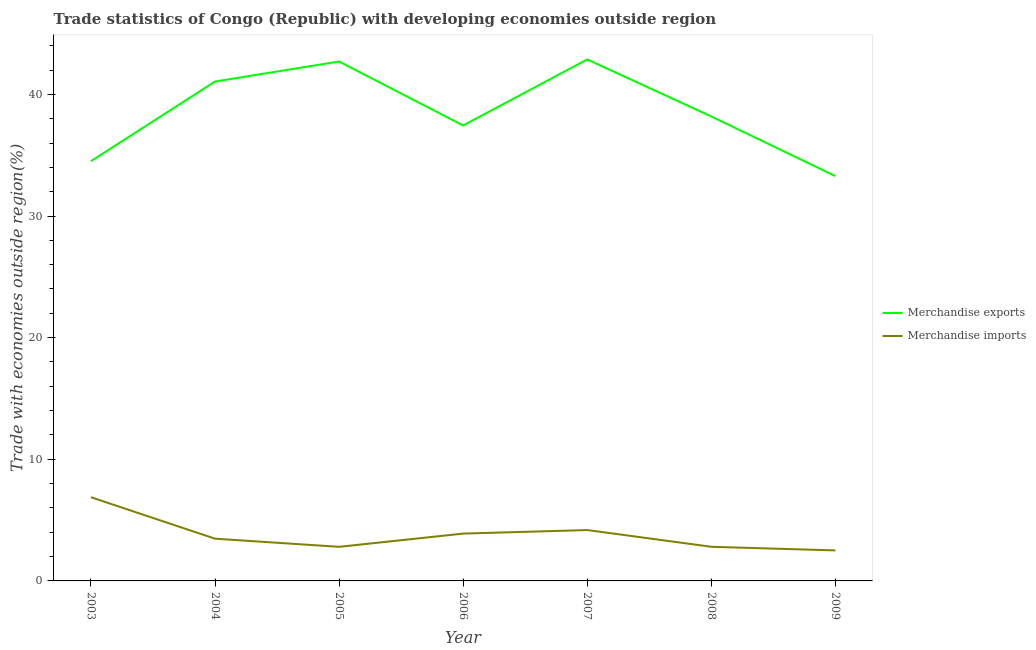How many different coloured lines are there?
Provide a succinct answer. 2. Is the number of lines equal to the number of legend labels?
Provide a succinct answer. Yes. What is the merchandise imports in 2008?
Give a very brief answer. 2.81. Across all years, what is the maximum merchandise imports?
Give a very brief answer. 6.88. Across all years, what is the minimum merchandise exports?
Provide a succinct answer. 33.28. What is the total merchandise exports in the graph?
Provide a short and direct response. 270.05. What is the difference between the merchandise imports in 2003 and that in 2007?
Offer a terse response. 2.7. What is the difference between the merchandise exports in 2006 and the merchandise imports in 2005?
Your response must be concise. 34.64. What is the average merchandise exports per year?
Your answer should be very brief. 38.58. In the year 2003, what is the difference between the merchandise imports and merchandise exports?
Offer a very short reply. -27.63. What is the ratio of the merchandise exports in 2006 to that in 2009?
Ensure brevity in your answer.  1.13. Is the difference between the merchandise exports in 2003 and 2007 greater than the difference between the merchandise imports in 2003 and 2007?
Your answer should be very brief. No. What is the difference between the highest and the second highest merchandise imports?
Provide a short and direct response. 2.7. What is the difference between the highest and the lowest merchandise exports?
Your answer should be very brief. 9.59. In how many years, is the merchandise exports greater than the average merchandise exports taken over all years?
Give a very brief answer. 3. Is the sum of the merchandise exports in 2007 and 2009 greater than the maximum merchandise imports across all years?
Your answer should be very brief. Yes. Is the merchandise exports strictly greater than the merchandise imports over the years?
Offer a very short reply. Yes. How many years are there in the graph?
Offer a very short reply. 7. Are the values on the major ticks of Y-axis written in scientific E-notation?
Keep it short and to the point. No. What is the title of the graph?
Offer a very short reply. Trade statistics of Congo (Republic) with developing economies outside region. What is the label or title of the X-axis?
Your response must be concise. Year. What is the label or title of the Y-axis?
Provide a succinct answer. Trade with economies outside region(%). What is the Trade with economies outside region(%) of Merchandise exports in 2003?
Provide a short and direct response. 34.51. What is the Trade with economies outside region(%) in Merchandise imports in 2003?
Your answer should be compact. 6.88. What is the Trade with economies outside region(%) in Merchandise exports in 2004?
Provide a succinct answer. 41.05. What is the Trade with economies outside region(%) of Merchandise imports in 2004?
Ensure brevity in your answer.  3.47. What is the Trade with economies outside region(%) in Merchandise exports in 2005?
Make the answer very short. 42.7. What is the Trade with economies outside region(%) in Merchandise imports in 2005?
Give a very brief answer. 2.8. What is the Trade with economies outside region(%) of Merchandise exports in 2006?
Provide a succinct answer. 37.44. What is the Trade with economies outside region(%) in Merchandise imports in 2006?
Your answer should be very brief. 3.89. What is the Trade with economies outside region(%) in Merchandise exports in 2007?
Your response must be concise. 42.87. What is the Trade with economies outside region(%) in Merchandise imports in 2007?
Give a very brief answer. 4.18. What is the Trade with economies outside region(%) of Merchandise exports in 2008?
Your response must be concise. 38.19. What is the Trade with economies outside region(%) of Merchandise imports in 2008?
Provide a succinct answer. 2.81. What is the Trade with economies outside region(%) of Merchandise exports in 2009?
Provide a succinct answer. 33.28. What is the Trade with economies outside region(%) in Merchandise imports in 2009?
Your answer should be very brief. 2.51. Across all years, what is the maximum Trade with economies outside region(%) in Merchandise exports?
Your response must be concise. 42.87. Across all years, what is the maximum Trade with economies outside region(%) in Merchandise imports?
Provide a short and direct response. 6.88. Across all years, what is the minimum Trade with economies outside region(%) of Merchandise exports?
Keep it short and to the point. 33.28. Across all years, what is the minimum Trade with economies outside region(%) in Merchandise imports?
Make the answer very short. 2.51. What is the total Trade with economies outside region(%) in Merchandise exports in the graph?
Provide a succinct answer. 270.05. What is the total Trade with economies outside region(%) in Merchandise imports in the graph?
Provide a succinct answer. 26.54. What is the difference between the Trade with economies outside region(%) of Merchandise exports in 2003 and that in 2004?
Keep it short and to the point. -6.55. What is the difference between the Trade with economies outside region(%) of Merchandise imports in 2003 and that in 2004?
Make the answer very short. 3.41. What is the difference between the Trade with economies outside region(%) of Merchandise exports in 2003 and that in 2005?
Your answer should be compact. -8.19. What is the difference between the Trade with economies outside region(%) in Merchandise imports in 2003 and that in 2005?
Offer a terse response. 4.08. What is the difference between the Trade with economies outside region(%) in Merchandise exports in 2003 and that in 2006?
Offer a terse response. -2.94. What is the difference between the Trade with economies outside region(%) of Merchandise imports in 2003 and that in 2006?
Give a very brief answer. 2.99. What is the difference between the Trade with economies outside region(%) in Merchandise exports in 2003 and that in 2007?
Your answer should be compact. -8.36. What is the difference between the Trade with economies outside region(%) of Merchandise imports in 2003 and that in 2007?
Offer a very short reply. 2.7. What is the difference between the Trade with economies outside region(%) of Merchandise exports in 2003 and that in 2008?
Your response must be concise. -3.68. What is the difference between the Trade with economies outside region(%) of Merchandise imports in 2003 and that in 2008?
Your response must be concise. 4.07. What is the difference between the Trade with economies outside region(%) in Merchandise exports in 2003 and that in 2009?
Give a very brief answer. 1.23. What is the difference between the Trade with economies outside region(%) of Merchandise imports in 2003 and that in 2009?
Offer a terse response. 4.37. What is the difference between the Trade with economies outside region(%) in Merchandise exports in 2004 and that in 2005?
Keep it short and to the point. -1.65. What is the difference between the Trade with economies outside region(%) of Merchandise imports in 2004 and that in 2005?
Provide a succinct answer. 0.67. What is the difference between the Trade with economies outside region(%) of Merchandise exports in 2004 and that in 2006?
Your answer should be compact. 3.61. What is the difference between the Trade with economies outside region(%) in Merchandise imports in 2004 and that in 2006?
Provide a short and direct response. -0.42. What is the difference between the Trade with economies outside region(%) of Merchandise exports in 2004 and that in 2007?
Your response must be concise. -1.82. What is the difference between the Trade with economies outside region(%) of Merchandise imports in 2004 and that in 2007?
Offer a very short reply. -0.71. What is the difference between the Trade with economies outside region(%) of Merchandise exports in 2004 and that in 2008?
Offer a very short reply. 2.87. What is the difference between the Trade with economies outside region(%) in Merchandise imports in 2004 and that in 2008?
Offer a very short reply. 0.67. What is the difference between the Trade with economies outside region(%) of Merchandise exports in 2004 and that in 2009?
Your answer should be compact. 7.77. What is the difference between the Trade with economies outside region(%) of Merchandise imports in 2004 and that in 2009?
Give a very brief answer. 0.96. What is the difference between the Trade with economies outside region(%) in Merchandise exports in 2005 and that in 2006?
Your answer should be very brief. 5.26. What is the difference between the Trade with economies outside region(%) in Merchandise imports in 2005 and that in 2006?
Provide a succinct answer. -1.09. What is the difference between the Trade with economies outside region(%) in Merchandise exports in 2005 and that in 2007?
Keep it short and to the point. -0.17. What is the difference between the Trade with economies outside region(%) of Merchandise imports in 2005 and that in 2007?
Make the answer very short. -1.38. What is the difference between the Trade with economies outside region(%) of Merchandise exports in 2005 and that in 2008?
Your answer should be compact. 4.51. What is the difference between the Trade with economies outside region(%) of Merchandise imports in 2005 and that in 2008?
Provide a succinct answer. -0. What is the difference between the Trade with economies outside region(%) in Merchandise exports in 2005 and that in 2009?
Provide a short and direct response. 9.42. What is the difference between the Trade with economies outside region(%) in Merchandise imports in 2005 and that in 2009?
Your answer should be very brief. 0.3. What is the difference between the Trade with economies outside region(%) in Merchandise exports in 2006 and that in 2007?
Provide a succinct answer. -5.43. What is the difference between the Trade with economies outside region(%) in Merchandise imports in 2006 and that in 2007?
Your answer should be very brief. -0.29. What is the difference between the Trade with economies outside region(%) of Merchandise exports in 2006 and that in 2008?
Provide a short and direct response. -0.74. What is the difference between the Trade with economies outside region(%) in Merchandise imports in 2006 and that in 2008?
Give a very brief answer. 1.08. What is the difference between the Trade with economies outside region(%) of Merchandise exports in 2006 and that in 2009?
Give a very brief answer. 4.16. What is the difference between the Trade with economies outside region(%) of Merchandise imports in 2006 and that in 2009?
Provide a short and direct response. 1.38. What is the difference between the Trade with economies outside region(%) in Merchandise exports in 2007 and that in 2008?
Offer a terse response. 4.69. What is the difference between the Trade with economies outside region(%) of Merchandise imports in 2007 and that in 2008?
Your answer should be very brief. 1.38. What is the difference between the Trade with economies outside region(%) of Merchandise exports in 2007 and that in 2009?
Provide a succinct answer. 9.59. What is the difference between the Trade with economies outside region(%) of Merchandise imports in 2007 and that in 2009?
Your response must be concise. 1.68. What is the difference between the Trade with economies outside region(%) in Merchandise exports in 2008 and that in 2009?
Offer a very short reply. 4.9. What is the difference between the Trade with economies outside region(%) in Merchandise imports in 2008 and that in 2009?
Provide a short and direct response. 0.3. What is the difference between the Trade with economies outside region(%) of Merchandise exports in 2003 and the Trade with economies outside region(%) of Merchandise imports in 2004?
Keep it short and to the point. 31.03. What is the difference between the Trade with economies outside region(%) of Merchandise exports in 2003 and the Trade with economies outside region(%) of Merchandise imports in 2005?
Your answer should be compact. 31.7. What is the difference between the Trade with economies outside region(%) in Merchandise exports in 2003 and the Trade with economies outside region(%) in Merchandise imports in 2006?
Provide a succinct answer. 30.62. What is the difference between the Trade with economies outside region(%) of Merchandise exports in 2003 and the Trade with economies outside region(%) of Merchandise imports in 2007?
Provide a short and direct response. 30.32. What is the difference between the Trade with economies outside region(%) of Merchandise exports in 2003 and the Trade with economies outside region(%) of Merchandise imports in 2008?
Ensure brevity in your answer.  31.7. What is the difference between the Trade with economies outside region(%) in Merchandise exports in 2003 and the Trade with economies outside region(%) in Merchandise imports in 2009?
Your answer should be very brief. 32. What is the difference between the Trade with economies outside region(%) in Merchandise exports in 2004 and the Trade with economies outside region(%) in Merchandise imports in 2005?
Your answer should be compact. 38.25. What is the difference between the Trade with economies outside region(%) in Merchandise exports in 2004 and the Trade with economies outside region(%) in Merchandise imports in 2006?
Make the answer very short. 37.16. What is the difference between the Trade with economies outside region(%) in Merchandise exports in 2004 and the Trade with economies outside region(%) in Merchandise imports in 2007?
Ensure brevity in your answer.  36.87. What is the difference between the Trade with economies outside region(%) of Merchandise exports in 2004 and the Trade with economies outside region(%) of Merchandise imports in 2008?
Your response must be concise. 38.25. What is the difference between the Trade with economies outside region(%) of Merchandise exports in 2004 and the Trade with economies outside region(%) of Merchandise imports in 2009?
Give a very brief answer. 38.55. What is the difference between the Trade with economies outside region(%) in Merchandise exports in 2005 and the Trade with economies outside region(%) in Merchandise imports in 2006?
Your answer should be compact. 38.81. What is the difference between the Trade with economies outside region(%) in Merchandise exports in 2005 and the Trade with economies outside region(%) in Merchandise imports in 2007?
Provide a short and direct response. 38.52. What is the difference between the Trade with economies outside region(%) of Merchandise exports in 2005 and the Trade with economies outside region(%) of Merchandise imports in 2008?
Your answer should be compact. 39.89. What is the difference between the Trade with economies outside region(%) in Merchandise exports in 2005 and the Trade with economies outside region(%) in Merchandise imports in 2009?
Offer a very short reply. 40.19. What is the difference between the Trade with economies outside region(%) in Merchandise exports in 2006 and the Trade with economies outside region(%) in Merchandise imports in 2007?
Your answer should be very brief. 33.26. What is the difference between the Trade with economies outside region(%) in Merchandise exports in 2006 and the Trade with economies outside region(%) in Merchandise imports in 2008?
Provide a succinct answer. 34.64. What is the difference between the Trade with economies outside region(%) in Merchandise exports in 2006 and the Trade with economies outside region(%) in Merchandise imports in 2009?
Make the answer very short. 34.94. What is the difference between the Trade with economies outside region(%) in Merchandise exports in 2007 and the Trade with economies outside region(%) in Merchandise imports in 2008?
Ensure brevity in your answer.  40.07. What is the difference between the Trade with economies outside region(%) in Merchandise exports in 2007 and the Trade with economies outside region(%) in Merchandise imports in 2009?
Your answer should be compact. 40.36. What is the difference between the Trade with economies outside region(%) in Merchandise exports in 2008 and the Trade with economies outside region(%) in Merchandise imports in 2009?
Provide a succinct answer. 35.68. What is the average Trade with economies outside region(%) in Merchandise exports per year?
Offer a terse response. 38.58. What is the average Trade with economies outside region(%) in Merchandise imports per year?
Provide a short and direct response. 3.79. In the year 2003, what is the difference between the Trade with economies outside region(%) of Merchandise exports and Trade with economies outside region(%) of Merchandise imports?
Your answer should be compact. 27.63. In the year 2004, what is the difference between the Trade with economies outside region(%) in Merchandise exports and Trade with economies outside region(%) in Merchandise imports?
Your response must be concise. 37.58. In the year 2005, what is the difference between the Trade with economies outside region(%) in Merchandise exports and Trade with economies outside region(%) in Merchandise imports?
Provide a succinct answer. 39.9. In the year 2006, what is the difference between the Trade with economies outside region(%) in Merchandise exports and Trade with economies outside region(%) in Merchandise imports?
Offer a terse response. 33.55. In the year 2007, what is the difference between the Trade with economies outside region(%) in Merchandise exports and Trade with economies outside region(%) in Merchandise imports?
Make the answer very short. 38.69. In the year 2008, what is the difference between the Trade with economies outside region(%) of Merchandise exports and Trade with economies outside region(%) of Merchandise imports?
Keep it short and to the point. 35.38. In the year 2009, what is the difference between the Trade with economies outside region(%) in Merchandise exports and Trade with economies outside region(%) in Merchandise imports?
Offer a terse response. 30.77. What is the ratio of the Trade with economies outside region(%) of Merchandise exports in 2003 to that in 2004?
Provide a short and direct response. 0.84. What is the ratio of the Trade with economies outside region(%) in Merchandise imports in 2003 to that in 2004?
Keep it short and to the point. 1.98. What is the ratio of the Trade with economies outside region(%) in Merchandise exports in 2003 to that in 2005?
Keep it short and to the point. 0.81. What is the ratio of the Trade with economies outside region(%) of Merchandise imports in 2003 to that in 2005?
Make the answer very short. 2.46. What is the ratio of the Trade with economies outside region(%) of Merchandise exports in 2003 to that in 2006?
Offer a terse response. 0.92. What is the ratio of the Trade with economies outside region(%) of Merchandise imports in 2003 to that in 2006?
Provide a succinct answer. 1.77. What is the ratio of the Trade with economies outside region(%) of Merchandise exports in 2003 to that in 2007?
Your answer should be very brief. 0.8. What is the ratio of the Trade with economies outside region(%) of Merchandise imports in 2003 to that in 2007?
Provide a succinct answer. 1.65. What is the ratio of the Trade with economies outside region(%) in Merchandise exports in 2003 to that in 2008?
Keep it short and to the point. 0.9. What is the ratio of the Trade with economies outside region(%) of Merchandise imports in 2003 to that in 2008?
Give a very brief answer. 2.45. What is the ratio of the Trade with economies outside region(%) of Merchandise exports in 2003 to that in 2009?
Provide a succinct answer. 1.04. What is the ratio of the Trade with economies outside region(%) of Merchandise imports in 2003 to that in 2009?
Ensure brevity in your answer.  2.74. What is the ratio of the Trade with economies outside region(%) in Merchandise exports in 2004 to that in 2005?
Provide a succinct answer. 0.96. What is the ratio of the Trade with economies outside region(%) in Merchandise imports in 2004 to that in 2005?
Your answer should be compact. 1.24. What is the ratio of the Trade with economies outside region(%) of Merchandise exports in 2004 to that in 2006?
Offer a terse response. 1.1. What is the ratio of the Trade with economies outside region(%) in Merchandise imports in 2004 to that in 2006?
Provide a succinct answer. 0.89. What is the ratio of the Trade with economies outside region(%) of Merchandise exports in 2004 to that in 2007?
Your response must be concise. 0.96. What is the ratio of the Trade with economies outside region(%) in Merchandise imports in 2004 to that in 2007?
Offer a very short reply. 0.83. What is the ratio of the Trade with economies outside region(%) in Merchandise exports in 2004 to that in 2008?
Your answer should be very brief. 1.08. What is the ratio of the Trade with economies outside region(%) of Merchandise imports in 2004 to that in 2008?
Your answer should be very brief. 1.24. What is the ratio of the Trade with economies outside region(%) in Merchandise exports in 2004 to that in 2009?
Make the answer very short. 1.23. What is the ratio of the Trade with economies outside region(%) of Merchandise imports in 2004 to that in 2009?
Keep it short and to the point. 1.38. What is the ratio of the Trade with economies outside region(%) of Merchandise exports in 2005 to that in 2006?
Keep it short and to the point. 1.14. What is the ratio of the Trade with economies outside region(%) of Merchandise imports in 2005 to that in 2006?
Your answer should be very brief. 0.72. What is the ratio of the Trade with economies outside region(%) in Merchandise exports in 2005 to that in 2007?
Your response must be concise. 1. What is the ratio of the Trade with economies outside region(%) of Merchandise imports in 2005 to that in 2007?
Ensure brevity in your answer.  0.67. What is the ratio of the Trade with economies outside region(%) of Merchandise exports in 2005 to that in 2008?
Offer a terse response. 1.12. What is the ratio of the Trade with economies outside region(%) in Merchandise imports in 2005 to that in 2008?
Your answer should be very brief. 1. What is the ratio of the Trade with economies outside region(%) of Merchandise exports in 2005 to that in 2009?
Make the answer very short. 1.28. What is the ratio of the Trade with economies outside region(%) of Merchandise imports in 2005 to that in 2009?
Offer a very short reply. 1.12. What is the ratio of the Trade with economies outside region(%) in Merchandise exports in 2006 to that in 2007?
Your answer should be very brief. 0.87. What is the ratio of the Trade with economies outside region(%) of Merchandise imports in 2006 to that in 2007?
Ensure brevity in your answer.  0.93. What is the ratio of the Trade with economies outside region(%) of Merchandise exports in 2006 to that in 2008?
Provide a short and direct response. 0.98. What is the ratio of the Trade with economies outside region(%) of Merchandise imports in 2006 to that in 2008?
Provide a short and direct response. 1.39. What is the ratio of the Trade with economies outside region(%) of Merchandise exports in 2006 to that in 2009?
Your answer should be very brief. 1.13. What is the ratio of the Trade with economies outside region(%) of Merchandise imports in 2006 to that in 2009?
Make the answer very short. 1.55. What is the ratio of the Trade with economies outside region(%) in Merchandise exports in 2007 to that in 2008?
Provide a short and direct response. 1.12. What is the ratio of the Trade with economies outside region(%) in Merchandise imports in 2007 to that in 2008?
Provide a short and direct response. 1.49. What is the ratio of the Trade with economies outside region(%) of Merchandise exports in 2007 to that in 2009?
Ensure brevity in your answer.  1.29. What is the ratio of the Trade with economies outside region(%) of Merchandise imports in 2007 to that in 2009?
Provide a short and direct response. 1.67. What is the ratio of the Trade with economies outside region(%) of Merchandise exports in 2008 to that in 2009?
Give a very brief answer. 1.15. What is the ratio of the Trade with economies outside region(%) of Merchandise imports in 2008 to that in 2009?
Give a very brief answer. 1.12. What is the difference between the highest and the second highest Trade with economies outside region(%) in Merchandise exports?
Provide a succinct answer. 0.17. What is the difference between the highest and the second highest Trade with economies outside region(%) of Merchandise imports?
Provide a short and direct response. 2.7. What is the difference between the highest and the lowest Trade with economies outside region(%) of Merchandise exports?
Ensure brevity in your answer.  9.59. What is the difference between the highest and the lowest Trade with economies outside region(%) in Merchandise imports?
Make the answer very short. 4.37. 